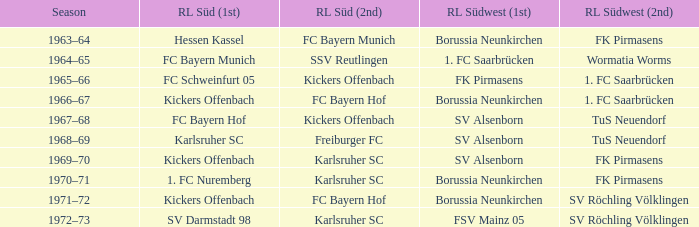In which season did sv darmstadt 98 finish at rl süd (1st)? 1972–73. 